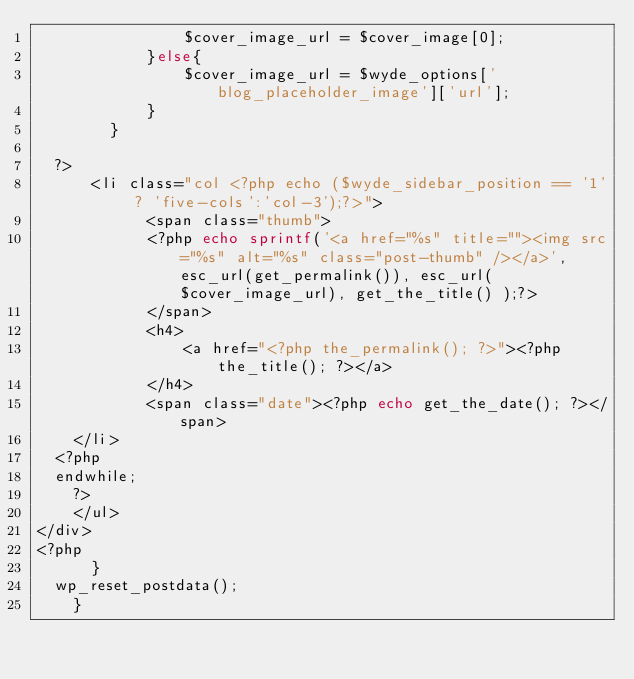Convert code to text. <code><loc_0><loc_0><loc_500><loc_500><_PHP_>                $cover_image_url = $cover_image[0];
            }else{
                $cover_image_url = $wyde_options['blog_placeholder_image']['url'];
            }
        }

	?>
	    <li class="col <?php echo ($wyde_sidebar_position == '1' ? 'five-cols':'col-3');?>">
            <span class="thumb">
            <?php echo sprintf('<a href="%s" title=""><img src="%s" alt="%s" class="post-thumb" /></a>', esc_url(get_permalink()), esc_url($cover_image_url), get_the_title() );?>
            </span>
            <h4>
                <a href="<?php the_permalink(); ?>"><?php the_title(); ?></a>
            </h4>
            <span class="date"><?php echo get_the_date(); ?></span>
		</li>
	<?php
	endwhile;
    ?>
    </ul>
</div>
<?php
	    }
	wp_reset_postdata();
    }</code> 